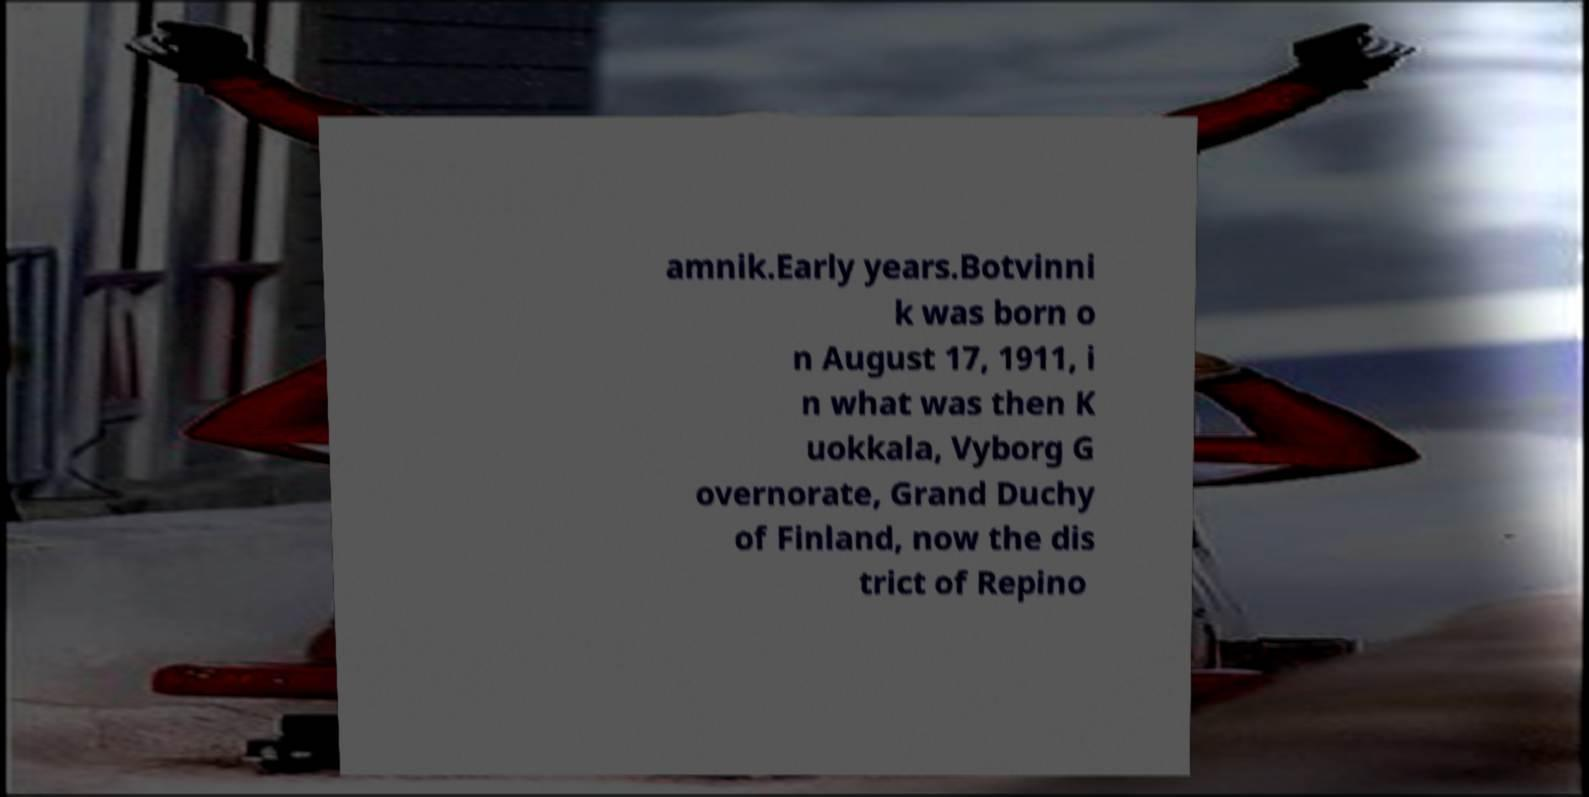Can you read and provide the text displayed in the image?This photo seems to have some interesting text. Can you extract and type it out for me? amnik.Early years.Botvinni k was born o n August 17, 1911, i n what was then K uokkala, Vyborg G overnorate, Grand Duchy of Finland, now the dis trict of Repino 